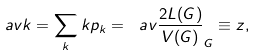<formula> <loc_0><loc_0><loc_500><loc_500>\ a v { k } = \sum _ { k } k p _ { k } = \ a v { \frac { 2 L ( G ) } { V ( G ) } } _ { G } \equiv z ,</formula> 